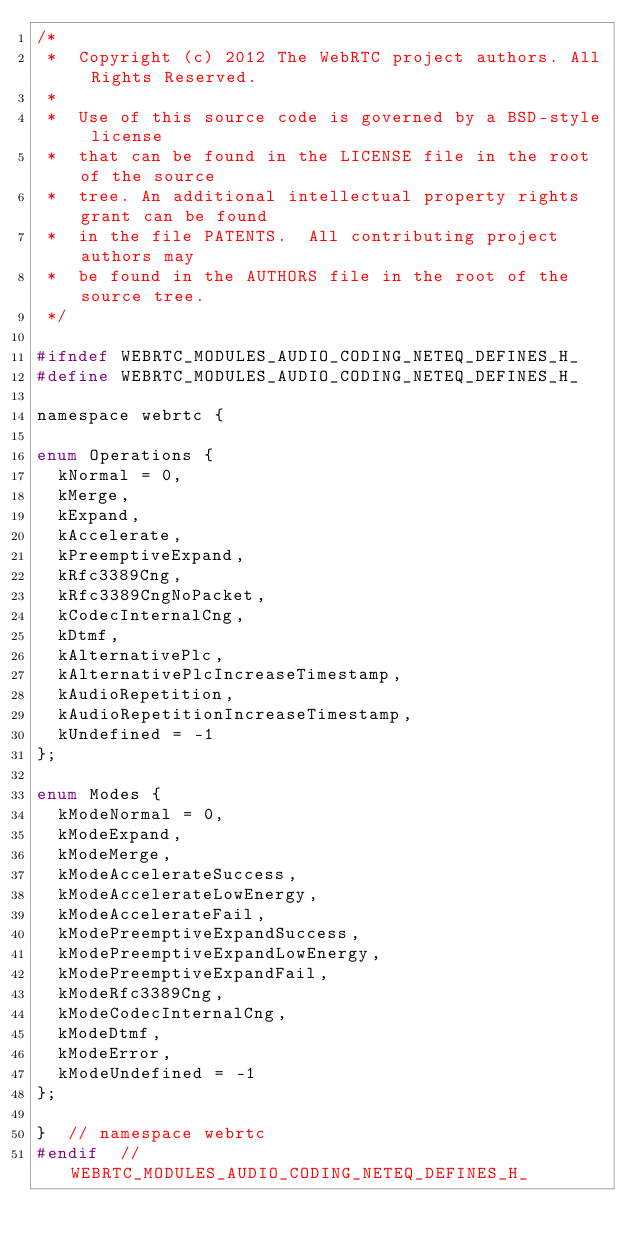Convert code to text. <code><loc_0><loc_0><loc_500><loc_500><_C_>/*
 *  Copyright (c) 2012 The WebRTC project authors. All Rights Reserved.
 *
 *  Use of this source code is governed by a BSD-style license
 *  that can be found in the LICENSE file in the root of the source
 *  tree. An additional intellectual property rights grant can be found
 *  in the file PATENTS.  All contributing project authors may
 *  be found in the AUTHORS file in the root of the source tree.
 */

#ifndef WEBRTC_MODULES_AUDIO_CODING_NETEQ_DEFINES_H_
#define WEBRTC_MODULES_AUDIO_CODING_NETEQ_DEFINES_H_

namespace webrtc {

enum Operations {
  kNormal = 0,
  kMerge,
  kExpand,
  kAccelerate,
  kPreemptiveExpand,
  kRfc3389Cng,
  kRfc3389CngNoPacket,
  kCodecInternalCng,
  kDtmf,
  kAlternativePlc,
  kAlternativePlcIncreaseTimestamp,
  kAudioRepetition,
  kAudioRepetitionIncreaseTimestamp,
  kUndefined = -1
};

enum Modes {
  kModeNormal = 0,
  kModeExpand,
  kModeMerge,
  kModeAccelerateSuccess,
  kModeAccelerateLowEnergy,
  kModeAccelerateFail,
  kModePreemptiveExpandSuccess,
  kModePreemptiveExpandLowEnergy,
  kModePreemptiveExpandFail,
  kModeRfc3389Cng,
  kModeCodecInternalCng,
  kModeDtmf,
  kModeError,
  kModeUndefined = -1
};

}  // namespace webrtc
#endif  // WEBRTC_MODULES_AUDIO_CODING_NETEQ_DEFINES_H_
</code> 